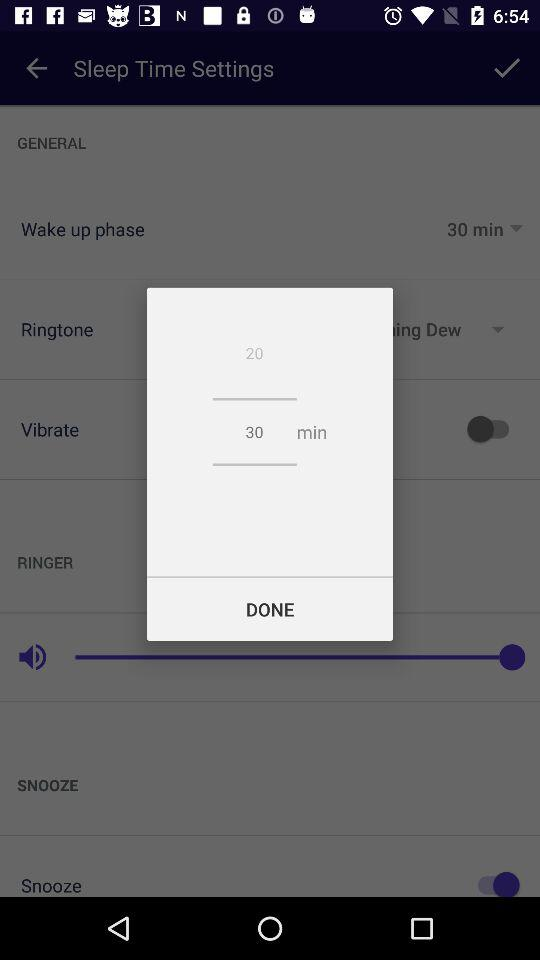How many minutes are selected? There are 30 minutes selected. 